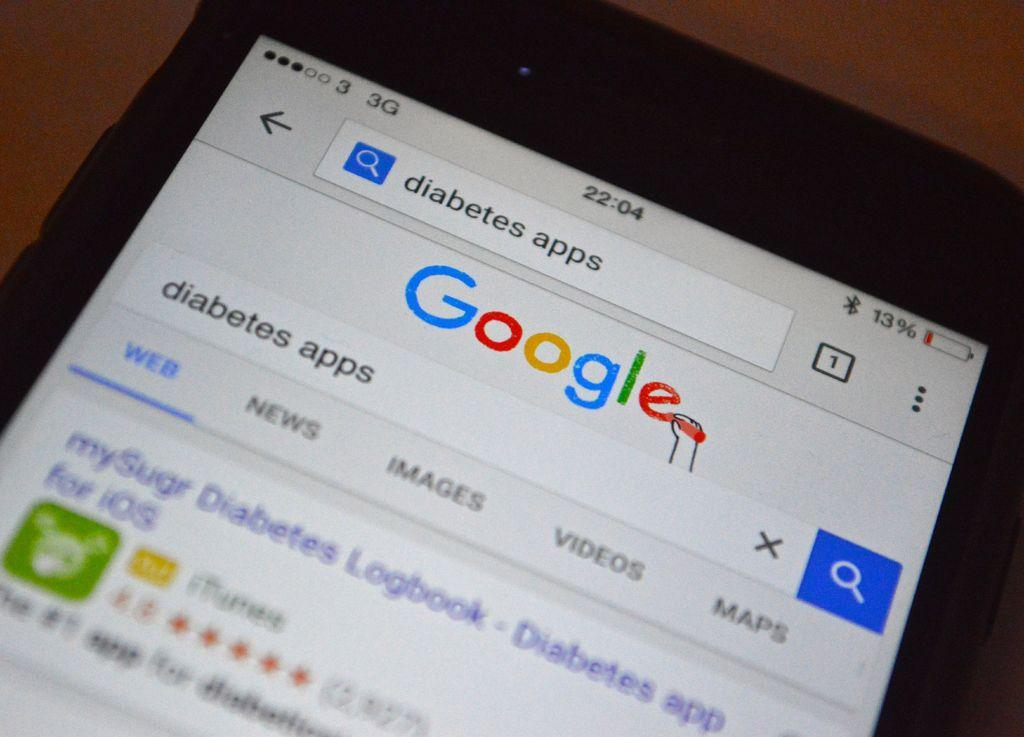<image>
Write a terse but informative summary of the picture. A phone showing, Google looking for diabetes app in the search bar 